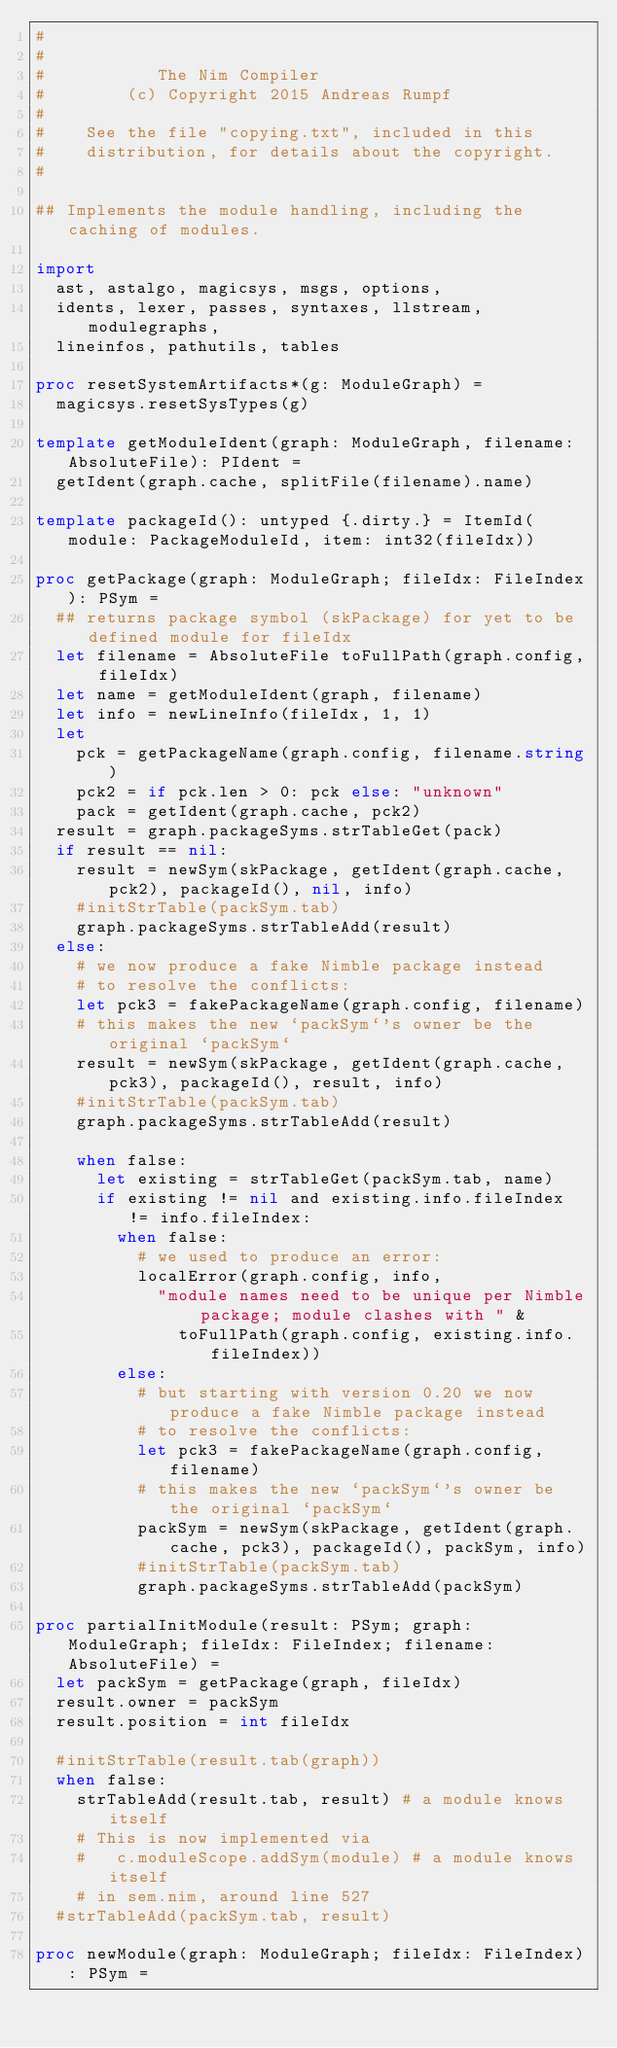Convert code to text. <code><loc_0><loc_0><loc_500><loc_500><_Nim_>#
#
#           The Nim Compiler
#        (c) Copyright 2015 Andreas Rumpf
#
#    See the file "copying.txt", included in this
#    distribution, for details about the copyright.
#

## Implements the module handling, including the caching of modules.

import
  ast, astalgo, magicsys, msgs, options,
  idents, lexer, passes, syntaxes, llstream, modulegraphs,
  lineinfos, pathutils, tables

proc resetSystemArtifacts*(g: ModuleGraph) =
  magicsys.resetSysTypes(g)

template getModuleIdent(graph: ModuleGraph, filename: AbsoluteFile): PIdent =
  getIdent(graph.cache, splitFile(filename).name)

template packageId(): untyped {.dirty.} = ItemId(module: PackageModuleId, item: int32(fileIdx))

proc getPackage(graph: ModuleGraph; fileIdx: FileIndex): PSym =
  ## returns package symbol (skPackage) for yet to be defined module for fileIdx
  let filename = AbsoluteFile toFullPath(graph.config, fileIdx)
  let name = getModuleIdent(graph, filename)
  let info = newLineInfo(fileIdx, 1, 1)
  let
    pck = getPackageName(graph.config, filename.string)
    pck2 = if pck.len > 0: pck else: "unknown"
    pack = getIdent(graph.cache, pck2)
  result = graph.packageSyms.strTableGet(pack)
  if result == nil:
    result = newSym(skPackage, getIdent(graph.cache, pck2), packageId(), nil, info)
    #initStrTable(packSym.tab)
    graph.packageSyms.strTableAdd(result)
  else:
    # we now produce a fake Nimble package instead
    # to resolve the conflicts:
    let pck3 = fakePackageName(graph.config, filename)
    # this makes the new `packSym`'s owner be the original `packSym`
    result = newSym(skPackage, getIdent(graph.cache, pck3), packageId(), result, info)
    #initStrTable(packSym.tab)
    graph.packageSyms.strTableAdd(result)

    when false:
      let existing = strTableGet(packSym.tab, name)
      if existing != nil and existing.info.fileIndex != info.fileIndex:
        when false:
          # we used to produce an error:
          localError(graph.config, info,
            "module names need to be unique per Nimble package; module clashes with " &
              toFullPath(graph.config, existing.info.fileIndex))
        else:
          # but starting with version 0.20 we now produce a fake Nimble package instead
          # to resolve the conflicts:
          let pck3 = fakePackageName(graph.config, filename)
          # this makes the new `packSym`'s owner be the original `packSym`
          packSym = newSym(skPackage, getIdent(graph.cache, pck3), packageId(), packSym, info)
          #initStrTable(packSym.tab)
          graph.packageSyms.strTableAdd(packSym)

proc partialInitModule(result: PSym; graph: ModuleGraph; fileIdx: FileIndex; filename: AbsoluteFile) =
  let packSym = getPackage(graph, fileIdx)
  result.owner = packSym
  result.position = int fileIdx

  #initStrTable(result.tab(graph))
  when false:
    strTableAdd(result.tab, result) # a module knows itself
    # This is now implemented via
    #   c.moduleScope.addSym(module) # a module knows itself
    # in sem.nim, around line 527
  #strTableAdd(packSym.tab, result)

proc newModule(graph: ModuleGraph; fileIdx: FileIndex): PSym =</code> 